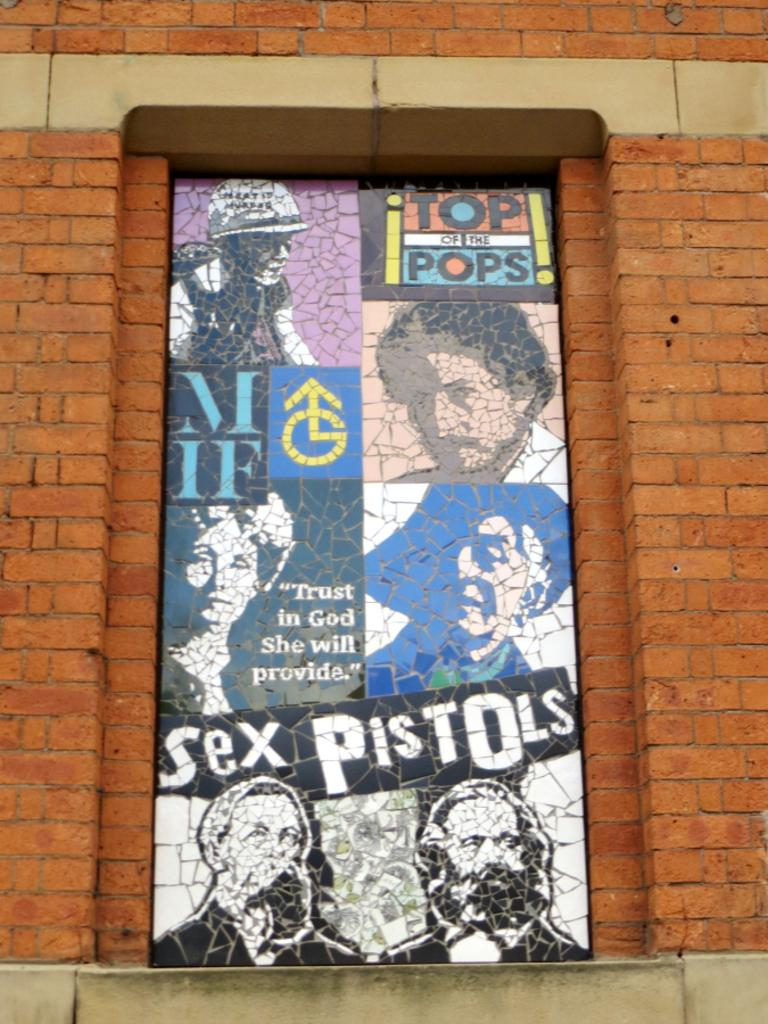Provide a one-sentence caption for the provided image. Sex Pistols are shown on this clever art display. 